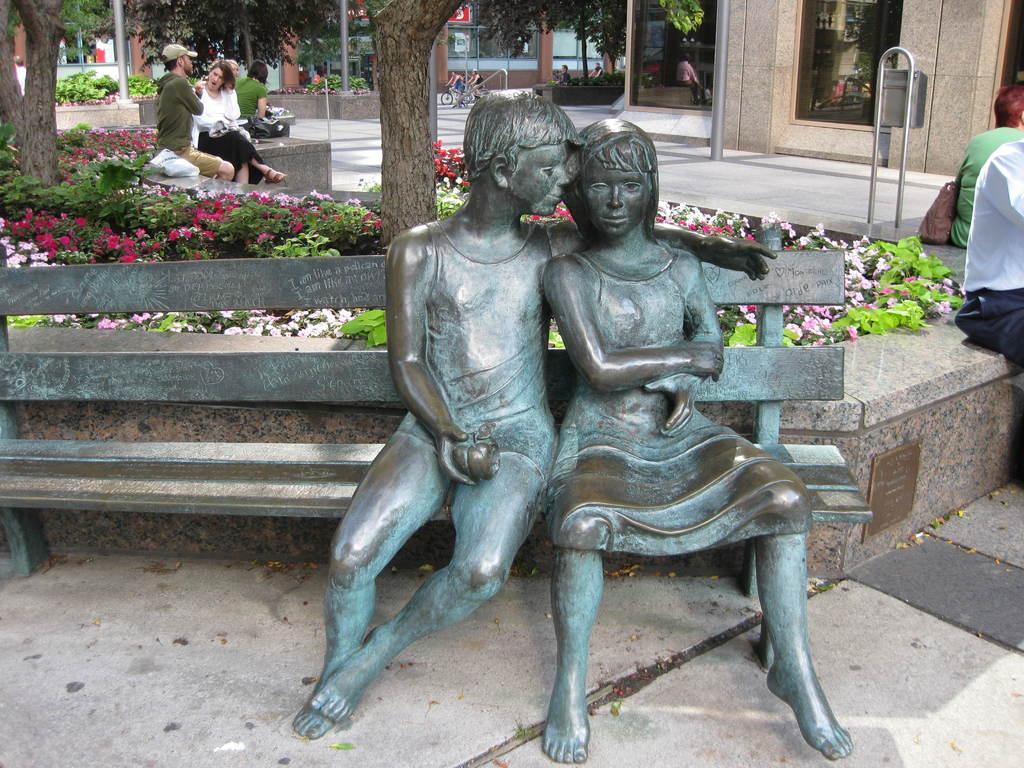Could you give a brief overview of what you see in this image? In the middle of the image we can see a statue. Behind the statue there are some plants and trees and few people are sitting. Behind them there are some buildings and few people are riding bicycles and there are some flowers. 